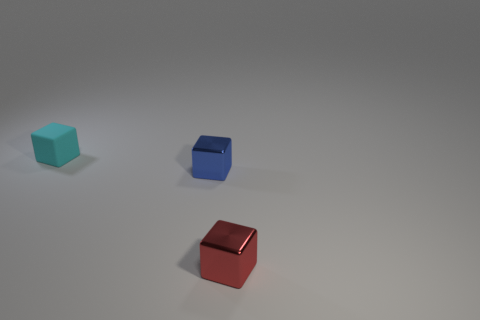Add 2 small yellow metallic balls. How many objects exist? 5 Subtract all tiny blue blocks. How many blocks are left? 2 Add 1 tiny cyan matte blocks. How many tiny cyan matte blocks exist? 2 Subtract all cyan blocks. How many blocks are left? 2 Subtract 0 blue spheres. How many objects are left? 3 Subtract 3 cubes. How many cubes are left? 0 Subtract all brown cubes. Subtract all brown spheres. How many cubes are left? 3 Subtract all small gray rubber cubes. Subtract all small red shiny cubes. How many objects are left? 2 Add 2 small red metal things. How many small red metal things are left? 3 